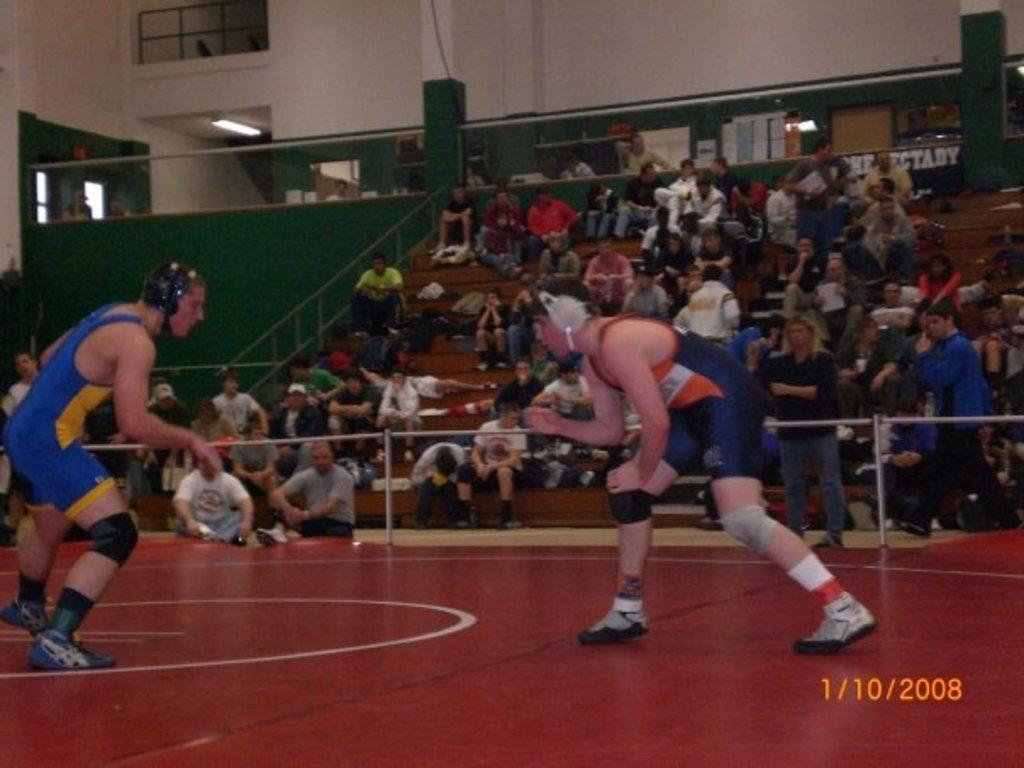How many persons are in the image? There are two persons standing in the center of the image. What is the surface on which the persons are standing? The persons are standing on the ground. What architectural features can be seen in the background of the image? There are stairs, a crowd, fencing, pillars, a door, a light, a wall, and a crowd in the background of the image. What type of trick is the grandmother performing in the image? There is no grandmother or trick present in the image. What type of laborer is visible in the image? There is no laborer present in the image. 